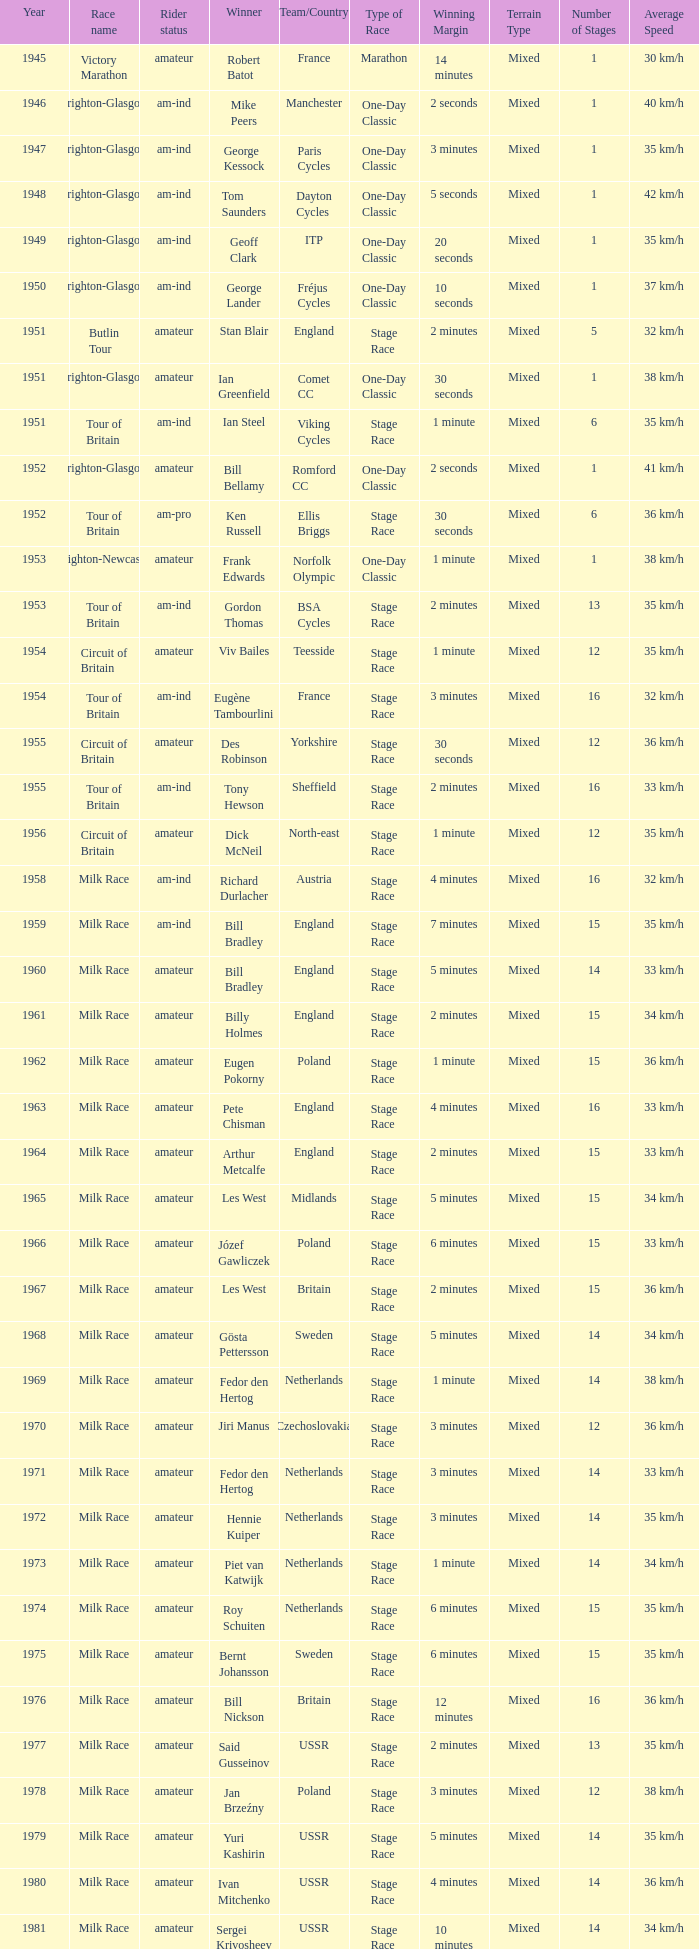What is the latest year when Phil Anderson won? 1993.0. 